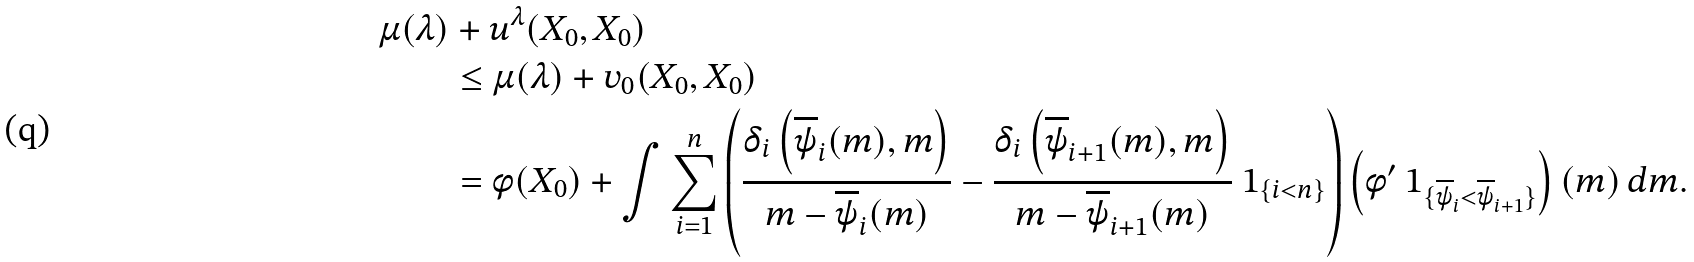<formula> <loc_0><loc_0><loc_500><loc_500>\mu ( \lambda ) & + u ^ { \lambda } ( X _ { 0 } , X _ { 0 } ) \\ & \leq \mu ( \lambda ) + v _ { 0 } ( X _ { 0 } , X _ { 0 } ) \\ & = \phi ( X _ { 0 } ) + \int \sum _ { i = 1 } ^ { n } \left ( \frac { \delta _ { i } \left ( \overline { \psi } _ { i } ( m ) , m \right ) } { m - \overline { \psi } _ { i } ( m ) } - \frac { \delta _ { i } \left ( \overline { \psi } _ { i + 1 } ( m ) , m \right ) } { m - \overline { \psi } _ { i + 1 } ( m ) } \ 1 _ { \{ i < n \} } \right ) \left ( \phi ^ { \prime } \ 1 _ { \{ \overline { \psi } _ { i } < \overline { \psi } _ { i + 1 } \} } \right ) ( m ) \, d m .</formula> 